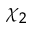Convert formula to latex. <formula><loc_0><loc_0><loc_500><loc_500>\chi _ { 2 }</formula> 